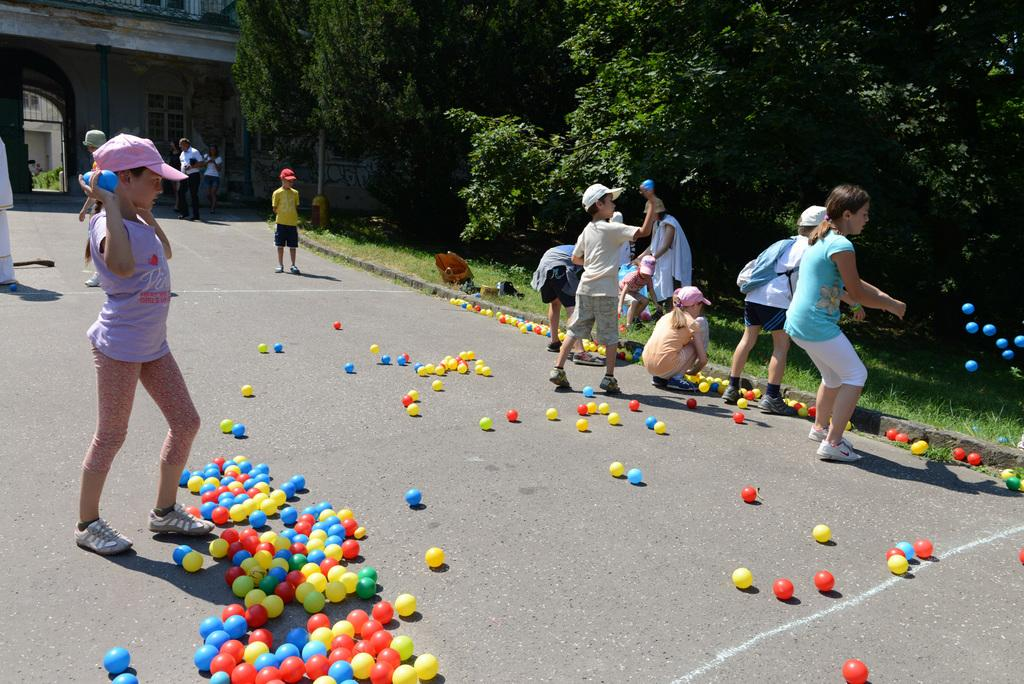What objects are on the road in the image? There are balls on the road in the image. Who is present in the image? There are kids in the image. What type of vegetation is on the right side of the image? There are trees on the right side of the image. What can be seen in the background of the image? There is a house in the background of the image. What type of toys are the kids playing with in the image? The provided facts do not mention any toys in the image, so we cannot determine what type of toys the kids might be playing with. 